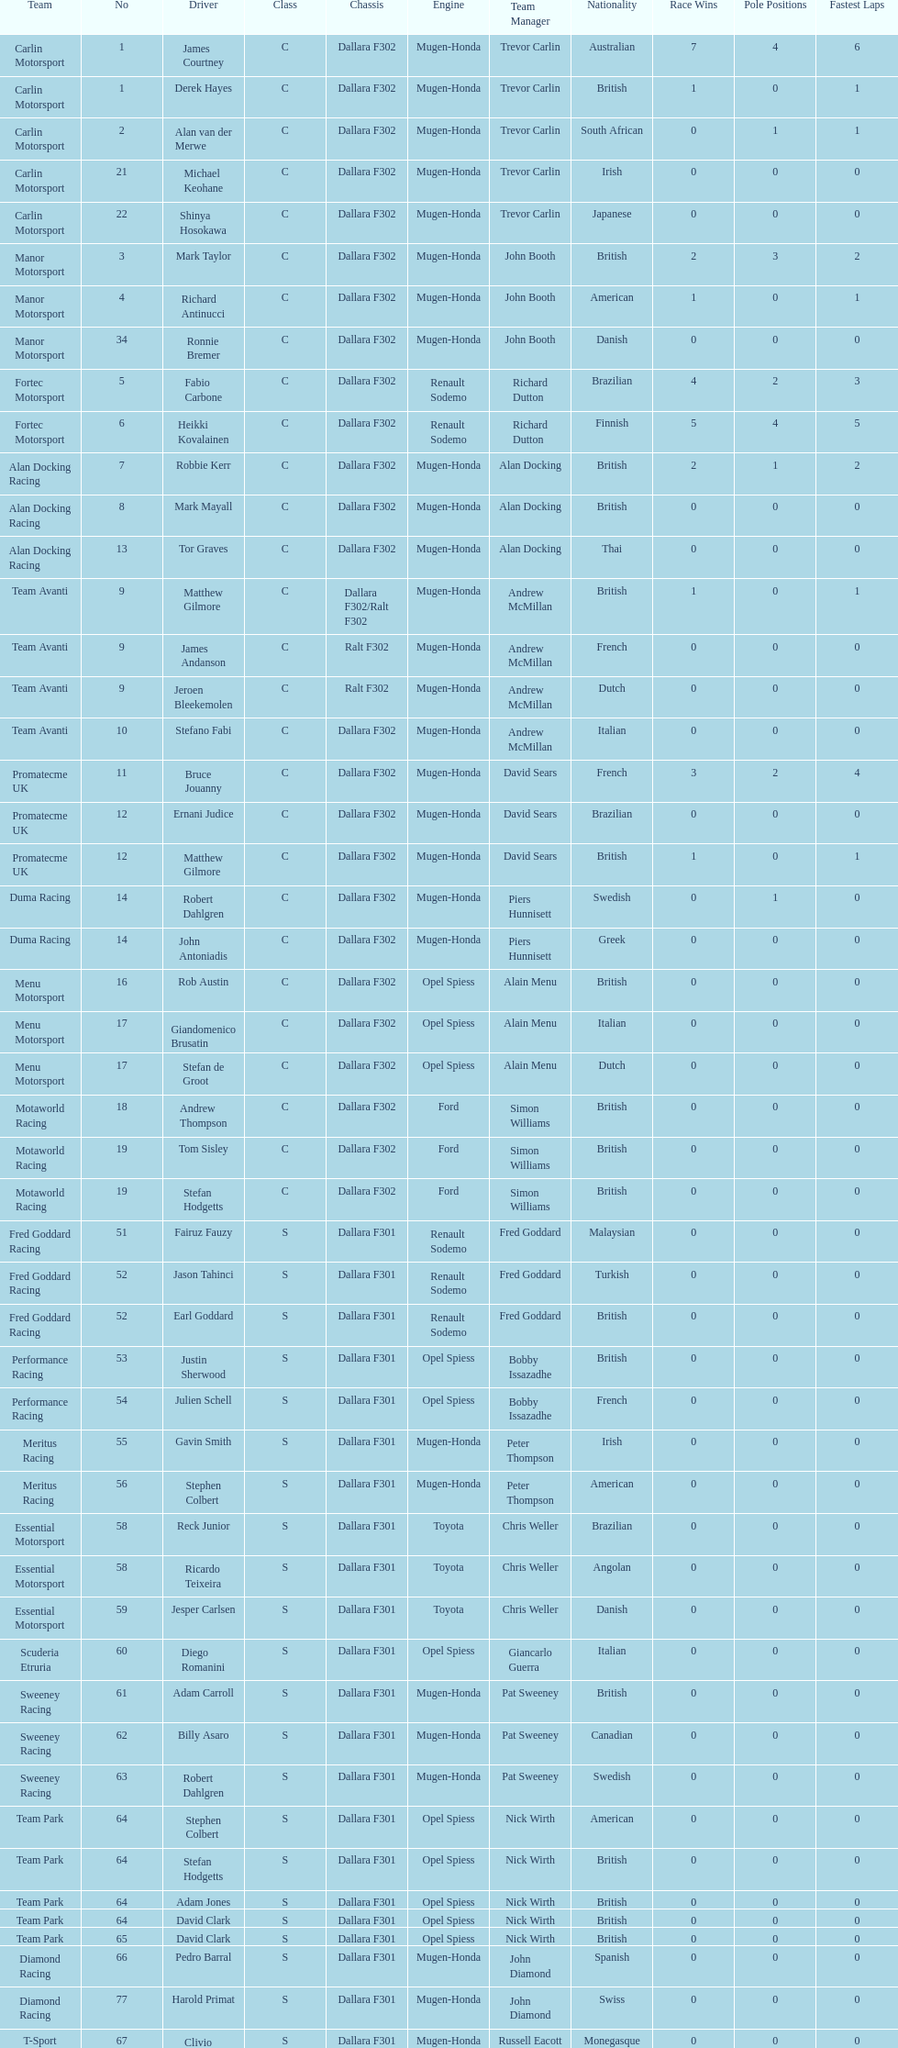The two drivers on t-sport are clivio piccione and what other driver? Karun Chandhok. 